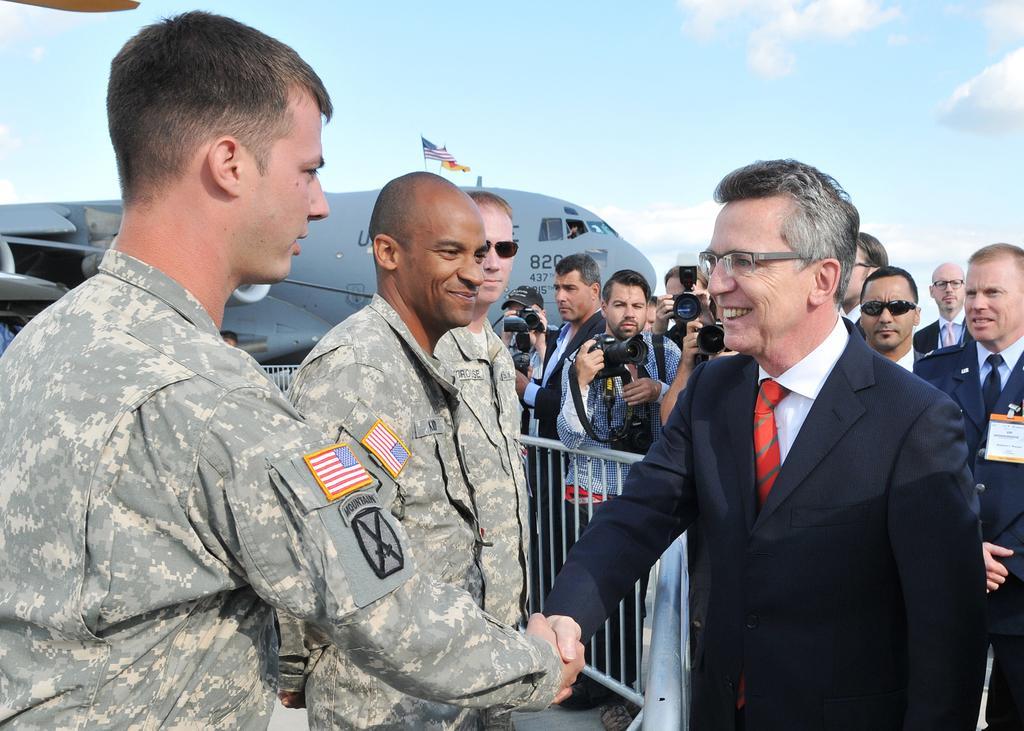How would you summarize this image in a sentence or two? In this image there are two officers in the middle who are shaking their hands with each other. Behind them there are camera mans standing near the fence by holding the cameras. In the background there is an airplane on which there are two flags. At the top there is the sky. 